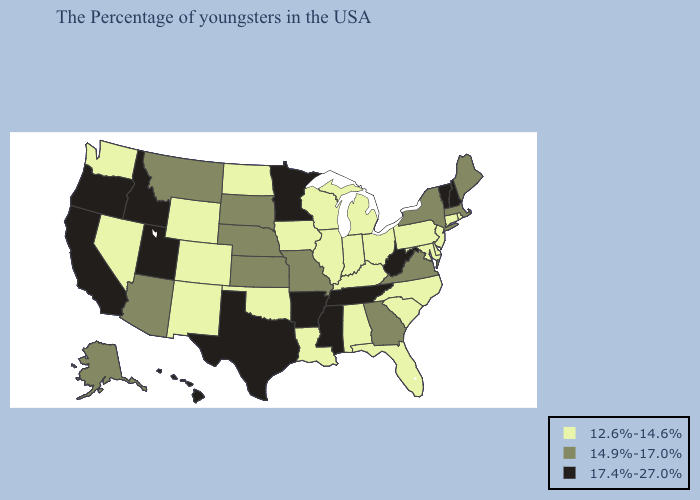Which states hav the highest value in the Northeast?
Short answer required. New Hampshire, Vermont. What is the highest value in states that border Georgia?
Give a very brief answer. 17.4%-27.0%. Which states have the highest value in the USA?
Concise answer only. New Hampshire, Vermont, West Virginia, Tennessee, Mississippi, Arkansas, Minnesota, Texas, Utah, Idaho, California, Oregon, Hawaii. What is the lowest value in the South?
Give a very brief answer. 12.6%-14.6%. What is the highest value in the USA?
Quick response, please. 17.4%-27.0%. What is the value of South Carolina?
Keep it brief. 12.6%-14.6%. Name the states that have a value in the range 14.9%-17.0%?
Be succinct. Maine, Massachusetts, New York, Virginia, Georgia, Missouri, Kansas, Nebraska, South Dakota, Montana, Arizona, Alaska. How many symbols are there in the legend?
Keep it brief. 3. Name the states that have a value in the range 17.4%-27.0%?
Concise answer only. New Hampshire, Vermont, West Virginia, Tennessee, Mississippi, Arkansas, Minnesota, Texas, Utah, Idaho, California, Oregon, Hawaii. What is the lowest value in the USA?
Write a very short answer. 12.6%-14.6%. Does Missouri have the highest value in the USA?
Concise answer only. No. Does the map have missing data?
Short answer required. No. Name the states that have a value in the range 12.6%-14.6%?
Concise answer only. Rhode Island, Connecticut, New Jersey, Delaware, Maryland, Pennsylvania, North Carolina, South Carolina, Ohio, Florida, Michigan, Kentucky, Indiana, Alabama, Wisconsin, Illinois, Louisiana, Iowa, Oklahoma, North Dakota, Wyoming, Colorado, New Mexico, Nevada, Washington. What is the value of Maine?
Write a very short answer. 14.9%-17.0%. What is the value of Kansas?
Quick response, please. 14.9%-17.0%. 